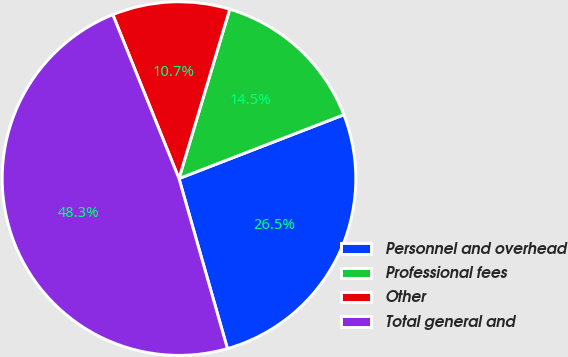Convert chart to OTSL. <chart><loc_0><loc_0><loc_500><loc_500><pie_chart><fcel>Personnel and overhead<fcel>Professional fees<fcel>Other<fcel>Total general and<nl><fcel>26.46%<fcel>14.49%<fcel>10.74%<fcel>48.31%<nl></chart> 